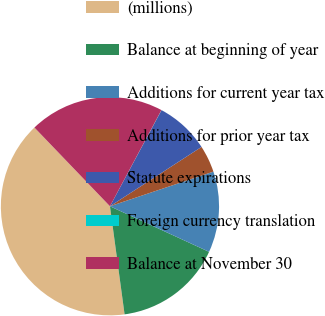<chart> <loc_0><loc_0><loc_500><loc_500><pie_chart><fcel>(millions)<fcel>Balance at beginning of year<fcel>Additions for current year tax<fcel>Additions for prior year tax<fcel>Statute expirations<fcel>Foreign currency translation<fcel>Balance at November 30<nl><fcel>39.97%<fcel>16.0%<fcel>12.0%<fcel>4.01%<fcel>8.01%<fcel>0.02%<fcel>19.99%<nl></chart> 